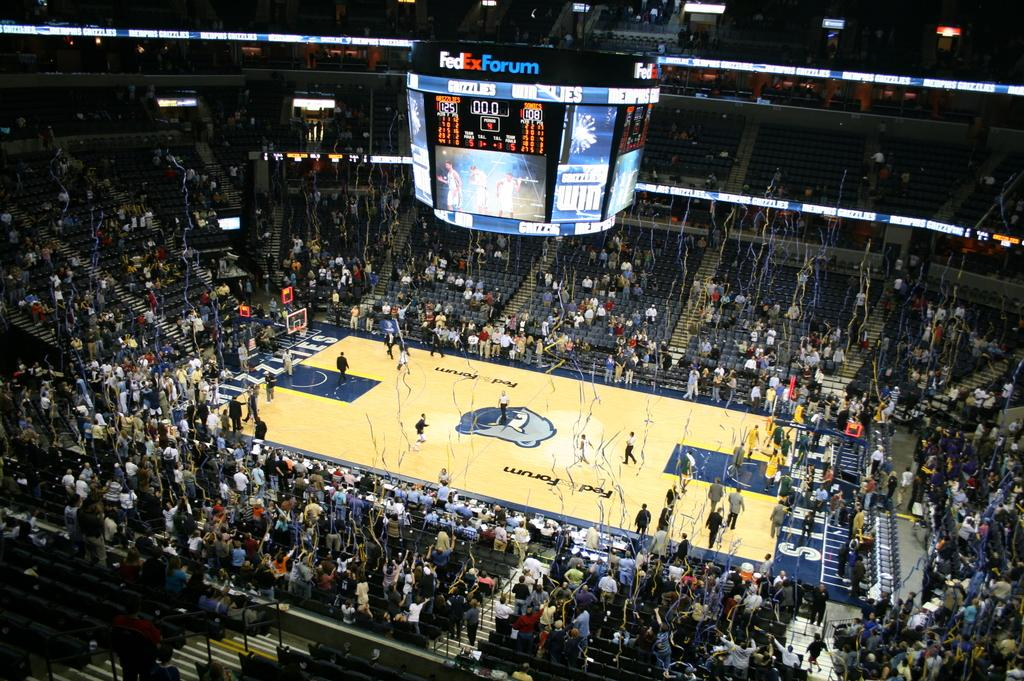<image>
Present a compact description of the photo's key features. Basketball staying for FedEx Forum showing confetti falling. 